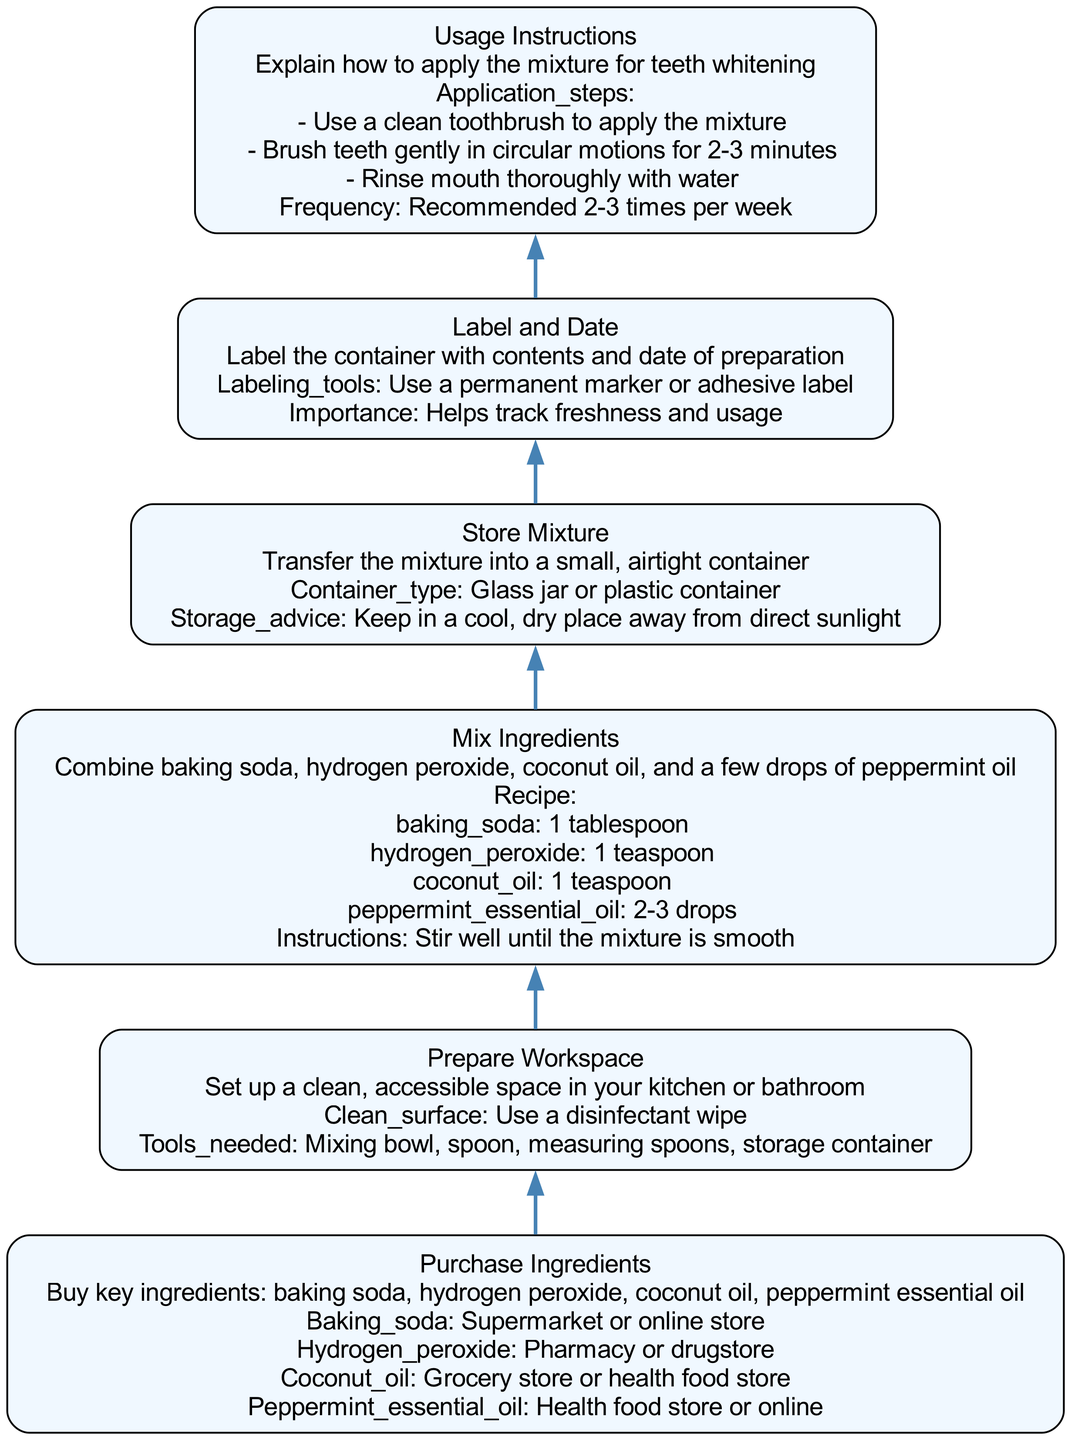What is the first step in preparing a DIY teeth whitening kit? The first step listed in the diagram is to "Purchase Ingredients," which involves buying key components such as baking soda and hydrogen peroxide. This is the bottommost node and represents the initial action required.
Answer: Purchase Ingredients What is the container type suggested for storing the mixture? The diagram specifies that the mixture should be stored in a "Glass jar or plastic container." This detail comes from the node labeled "Store Mixture," which outlines the storage requirements.
Answer: Glass jar or plastic container How many drops of peppermint essential oil are recommended in the mixture? According to the node "Mix Ingredients," it suggests adding "2-3 drops" of peppermint essential oil to the mixture. This information is found within the details of that specific node.
Answer: 2-3 drops What is one tool needed for preparing the workspace? Reviewing the node "Prepare Workspace," one of the tools needed is a "Mixing bowl." The node describes a clean and accessible space set up for mixing ingredients, including necessary tools.
Answer: Mixing bowl What is the frequency of usage recommended for the whitening mixture? The node "Usage Instructions" states that the mixture should be applied "2-3 times per week." This indicates how often one should use the homemade whitening kit for optimal results.
Answer: 2-3 times per week What should you label on the container after preparing the mixture? The node "Label and Date" indicates that you should label the container with "contents and date of preparation." This serves to track freshness and when the mixture was made.
Answer: Contents and date of preparation Which two ingredients are specified to purchase from a supermarket? In the "Purchase Ingredients" node, it lists "baking soda" and "coconut oil" as key ingredients, with "baking soda" being available at a supermarket. Therefore, both fall under supermarket purchases.
Answer: Baking soda and coconut oil What steps should be taken to apply the whitening mixture? The application steps are detailed under "Usage Instructions" where it outlines three specific actions: applying with a toothbrush, brushing in circular motions, and rinsing thoroughly. These steps guide how to use the mixture effectively.
Answer: Use a clean toothbrush, brush teeth gently, rinse mouth thoroughly 